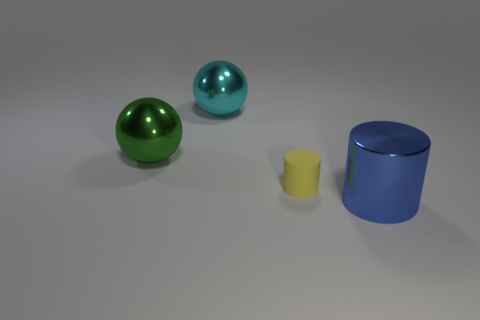How do the textures of the objects compare? In the image, the sphere and cylinder show highly reflective surfaces, indicating they are smooth and likely metallic or polished. The small cylinder appears to have a slightly matte finish, indicating a different, less reflective texture. 